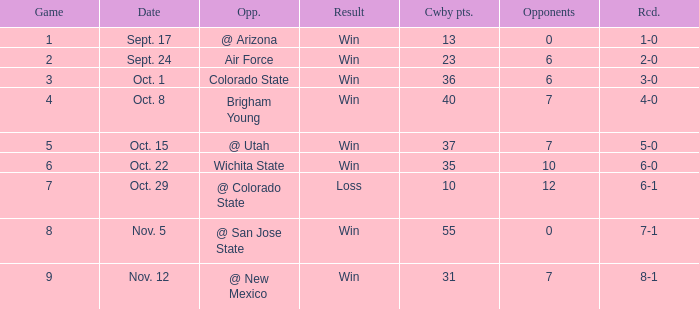What was the Cowboys' record for Nov. 5, 1966? 7-1. 